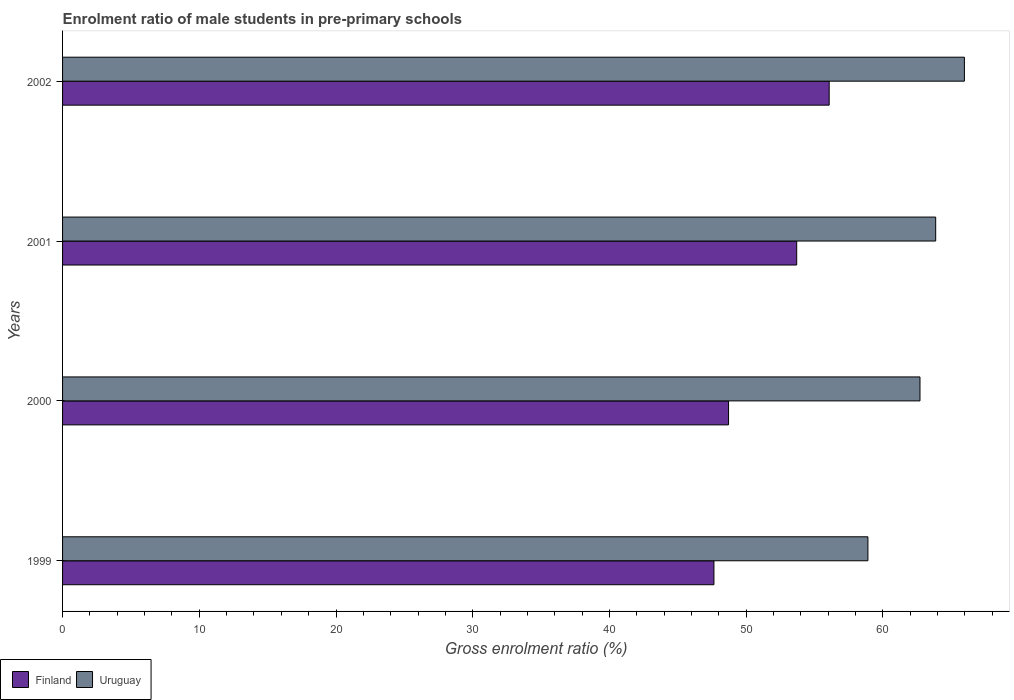How many groups of bars are there?
Give a very brief answer. 4. Are the number of bars per tick equal to the number of legend labels?
Provide a succinct answer. Yes. How many bars are there on the 4th tick from the bottom?
Your answer should be compact. 2. What is the enrolment ratio of male students in pre-primary schools in Uruguay in 2001?
Provide a succinct answer. 63.86. Across all years, what is the maximum enrolment ratio of male students in pre-primary schools in Uruguay?
Your answer should be very brief. 65.96. Across all years, what is the minimum enrolment ratio of male students in pre-primary schools in Finland?
Your answer should be compact. 47.64. In which year was the enrolment ratio of male students in pre-primary schools in Finland maximum?
Provide a short and direct response. 2002. What is the total enrolment ratio of male students in pre-primary schools in Finland in the graph?
Your answer should be very brief. 206.12. What is the difference between the enrolment ratio of male students in pre-primary schools in Uruguay in 1999 and that in 2001?
Your answer should be compact. -4.96. What is the difference between the enrolment ratio of male students in pre-primary schools in Finland in 2000 and the enrolment ratio of male students in pre-primary schools in Uruguay in 2002?
Provide a short and direct response. -17.25. What is the average enrolment ratio of male students in pre-primary schools in Uruguay per year?
Provide a short and direct response. 62.86. In the year 2000, what is the difference between the enrolment ratio of male students in pre-primary schools in Finland and enrolment ratio of male students in pre-primary schools in Uruguay?
Provide a succinct answer. -14. What is the ratio of the enrolment ratio of male students in pre-primary schools in Finland in 1999 to that in 2001?
Provide a succinct answer. 0.89. What is the difference between the highest and the second highest enrolment ratio of male students in pre-primary schools in Finland?
Offer a very short reply. 2.38. What is the difference between the highest and the lowest enrolment ratio of male students in pre-primary schools in Uruguay?
Your answer should be very brief. 7.06. What does the 1st bar from the top in 1999 represents?
Ensure brevity in your answer.  Uruguay. What does the 2nd bar from the bottom in 2002 represents?
Your answer should be compact. Uruguay. How many bars are there?
Your answer should be compact. 8. Are all the bars in the graph horizontal?
Your answer should be very brief. Yes. Where does the legend appear in the graph?
Make the answer very short. Bottom left. What is the title of the graph?
Ensure brevity in your answer.  Enrolment ratio of male students in pre-primary schools. Does "Netherlands" appear as one of the legend labels in the graph?
Your answer should be compact. No. What is the label or title of the X-axis?
Your response must be concise. Gross enrolment ratio (%). What is the Gross enrolment ratio (%) of Finland in 1999?
Provide a succinct answer. 47.64. What is the Gross enrolment ratio (%) in Uruguay in 1999?
Ensure brevity in your answer.  58.9. What is the Gross enrolment ratio (%) in Finland in 2000?
Keep it short and to the point. 48.71. What is the Gross enrolment ratio (%) of Uruguay in 2000?
Offer a terse response. 62.71. What is the Gross enrolment ratio (%) in Finland in 2001?
Offer a terse response. 53.7. What is the Gross enrolment ratio (%) in Uruguay in 2001?
Provide a short and direct response. 63.86. What is the Gross enrolment ratio (%) in Finland in 2002?
Give a very brief answer. 56.07. What is the Gross enrolment ratio (%) in Uruguay in 2002?
Provide a short and direct response. 65.96. Across all years, what is the maximum Gross enrolment ratio (%) of Finland?
Ensure brevity in your answer.  56.07. Across all years, what is the maximum Gross enrolment ratio (%) of Uruguay?
Offer a terse response. 65.96. Across all years, what is the minimum Gross enrolment ratio (%) in Finland?
Give a very brief answer. 47.64. Across all years, what is the minimum Gross enrolment ratio (%) in Uruguay?
Offer a very short reply. 58.9. What is the total Gross enrolment ratio (%) in Finland in the graph?
Your response must be concise. 206.12. What is the total Gross enrolment ratio (%) of Uruguay in the graph?
Your answer should be compact. 251.44. What is the difference between the Gross enrolment ratio (%) of Finland in 1999 and that in 2000?
Ensure brevity in your answer.  -1.07. What is the difference between the Gross enrolment ratio (%) of Uruguay in 1999 and that in 2000?
Ensure brevity in your answer.  -3.81. What is the difference between the Gross enrolment ratio (%) in Finland in 1999 and that in 2001?
Your answer should be compact. -6.05. What is the difference between the Gross enrolment ratio (%) in Uruguay in 1999 and that in 2001?
Make the answer very short. -4.96. What is the difference between the Gross enrolment ratio (%) of Finland in 1999 and that in 2002?
Ensure brevity in your answer.  -8.43. What is the difference between the Gross enrolment ratio (%) in Uruguay in 1999 and that in 2002?
Your response must be concise. -7.06. What is the difference between the Gross enrolment ratio (%) in Finland in 2000 and that in 2001?
Provide a short and direct response. -4.99. What is the difference between the Gross enrolment ratio (%) in Uruguay in 2000 and that in 2001?
Give a very brief answer. -1.15. What is the difference between the Gross enrolment ratio (%) of Finland in 2000 and that in 2002?
Make the answer very short. -7.36. What is the difference between the Gross enrolment ratio (%) in Uruguay in 2000 and that in 2002?
Keep it short and to the point. -3.25. What is the difference between the Gross enrolment ratio (%) in Finland in 2001 and that in 2002?
Offer a terse response. -2.38. What is the difference between the Gross enrolment ratio (%) in Uruguay in 2001 and that in 2002?
Provide a succinct answer. -2.1. What is the difference between the Gross enrolment ratio (%) in Finland in 1999 and the Gross enrolment ratio (%) in Uruguay in 2000?
Keep it short and to the point. -15.07. What is the difference between the Gross enrolment ratio (%) of Finland in 1999 and the Gross enrolment ratio (%) of Uruguay in 2001?
Offer a terse response. -16.22. What is the difference between the Gross enrolment ratio (%) in Finland in 1999 and the Gross enrolment ratio (%) in Uruguay in 2002?
Give a very brief answer. -18.32. What is the difference between the Gross enrolment ratio (%) in Finland in 2000 and the Gross enrolment ratio (%) in Uruguay in 2001?
Your answer should be very brief. -15.15. What is the difference between the Gross enrolment ratio (%) of Finland in 2000 and the Gross enrolment ratio (%) of Uruguay in 2002?
Offer a very short reply. -17.25. What is the difference between the Gross enrolment ratio (%) of Finland in 2001 and the Gross enrolment ratio (%) of Uruguay in 2002?
Offer a very short reply. -12.27. What is the average Gross enrolment ratio (%) in Finland per year?
Keep it short and to the point. 51.53. What is the average Gross enrolment ratio (%) of Uruguay per year?
Give a very brief answer. 62.86. In the year 1999, what is the difference between the Gross enrolment ratio (%) in Finland and Gross enrolment ratio (%) in Uruguay?
Offer a very short reply. -11.26. In the year 2000, what is the difference between the Gross enrolment ratio (%) in Finland and Gross enrolment ratio (%) in Uruguay?
Ensure brevity in your answer.  -14. In the year 2001, what is the difference between the Gross enrolment ratio (%) in Finland and Gross enrolment ratio (%) in Uruguay?
Offer a very short reply. -10.17. In the year 2002, what is the difference between the Gross enrolment ratio (%) in Finland and Gross enrolment ratio (%) in Uruguay?
Make the answer very short. -9.89. What is the ratio of the Gross enrolment ratio (%) of Finland in 1999 to that in 2000?
Your response must be concise. 0.98. What is the ratio of the Gross enrolment ratio (%) of Uruguay in 1999 to that in 2000?
Your response must be concise. 0.94. What is the ratio of the Gross enrolment ratio (%) in Finland in 1999 to that in 2001?
Your answer should be very brief. 0.89. What is the ratio of the Gross enrolment ratio (%) of Uruguay in 1999 to that in 2001?
Give a very brief answer. 0.92. What is the ratio of the Gross enrolment ratio (%) in Finland in 1999 to that in 2002?
Your answer should be very brief. 0.85. What is the ratio of the Gross enrolment ratio (%) in Uruguay in 1999 to that in 2002?
Your answer should be compact. 0.89. What is the ratio of the Gross enrolment ratio (%) of Finland in 2000 to that in 2001?
Ensure brevity in your answer.  0.91. What is the ratio of the Gross enrolment ratio (%) of Finland in 2000 to that in 2002?
Give a very brief answer. 0.87. What is the ratio of the Gross enrolment ratio (%) of Uruguay in 2000 to that in 2002?
Offer a very short reply. 0.95. What is the ratio of the Gross enrolment ratio (%) of Finland in 2001 to that in 2002?
Give a very brief answer. 0.96. What is the ratio of the Gross enrolment ratio (%) of Uruguay in 2001 to that in 2002?
Offer a very short reply. 0.97. What is the difference between the highest and the second highest Gross enrolment ratio (%) in Finland?
Offer a terse response. 2.38. What is the difference between the highest and the second highest Gross enrolment ratio (%) of Uruguay?
Your answer should be very brief. 2.1. What is the difference between the highest and the lowest Gross enrolment ratio (%) in Finland?
Keep it short and to the point. 8.43. What is the difference between the highest and the lowest Gross enrolment ratio (%) in Uruguay?
Offer a very short reply. 7.06. 